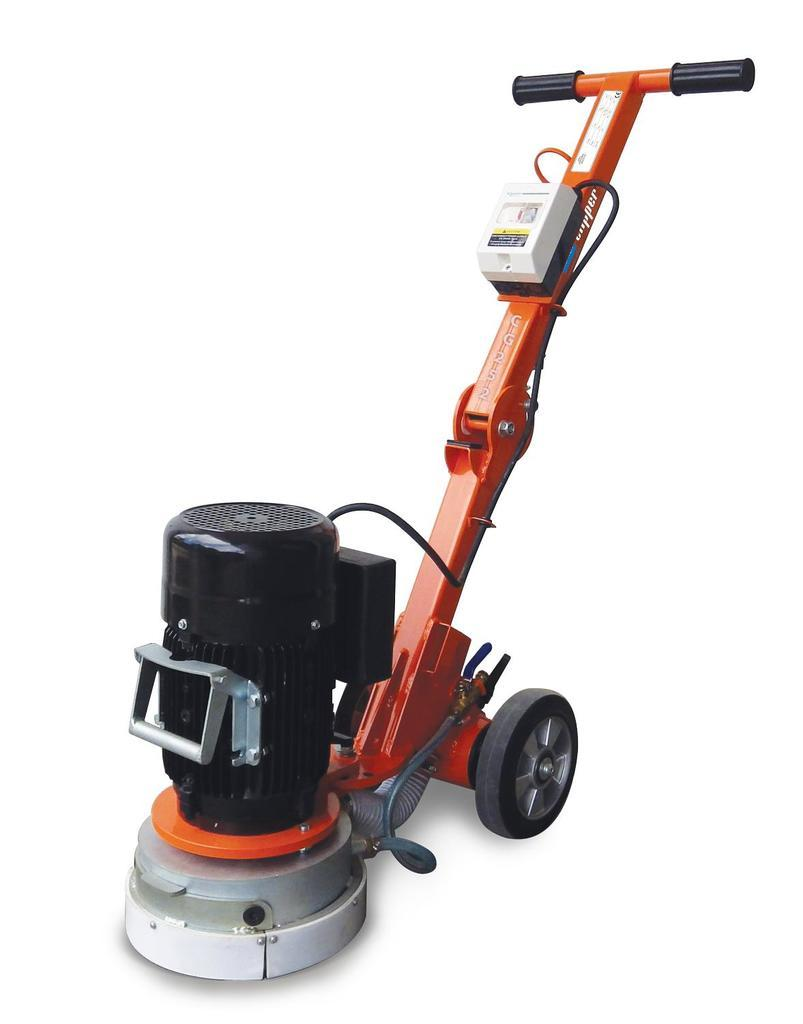What is the main object in the image? There is a machine in the image. What color is the machine? The machine is orange in color. Does the machine have any specific features? Yes, the machine has wheels. How does the machine claim its territory in the image? There is no indication in the image that the machine is claiming territory, as machines do not have the ability to claim territory. 